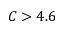Convert formula to latex. <formula><loc_0><loc_0><loc_500><loc_500>C > 4 . 6</formula> 